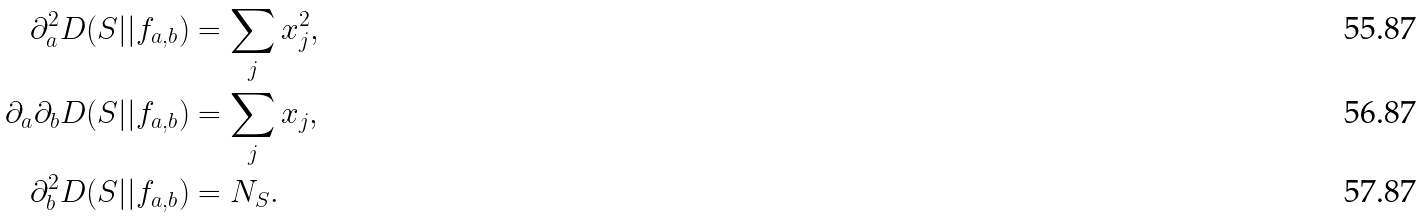<formula> <loc_0><loc_0><loc_500><loc_500>\partial _ { a } ^ { 2 } D ( S | | f _ { a , b } ) & = \sum _ { j } x _ { j } ^ { 2 } , \\ \partial _ { a } \partial _ { b } D ( S | | f _ { a , b } ) & = \sum _ { j } x _ { j } , \\ \partial ^ { 2 } _ { b } D ( S | | f _ { a , b } ) & = N _ { S } .</formula> 